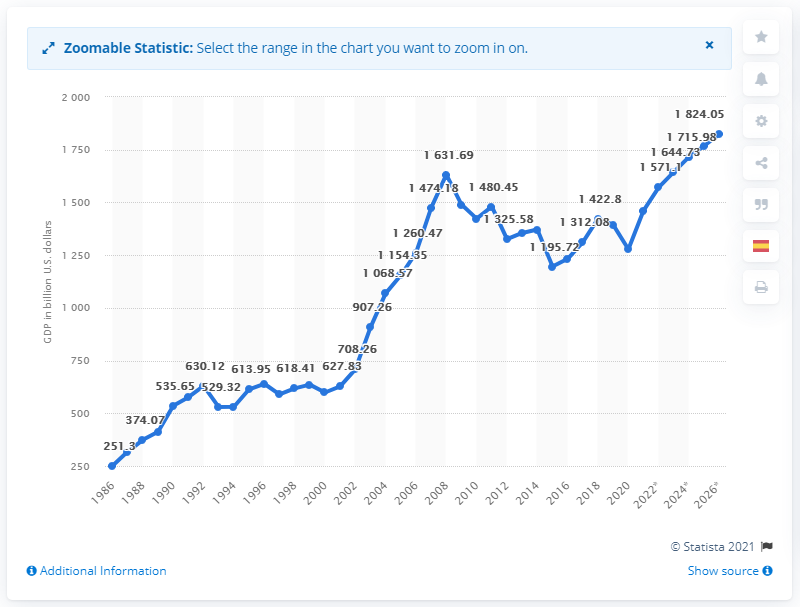Give some essential details in this illustration. In 2020, the Gross Domestic Product (GDP) of Spain was 1278.21 billion dollars. 